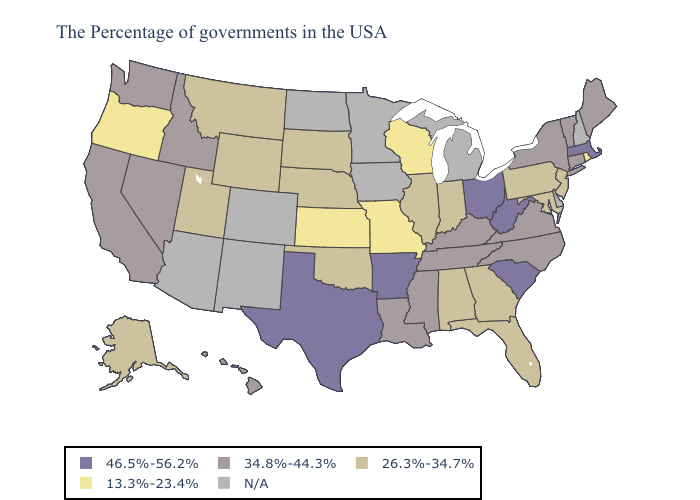What is the lowest value in the Northeast?
Short answer required. 13.3%-23.4%. Does Ohio have the highest value in the USA?
Write a very short answer. Yes. Does Texas have the highest value in the South?
Write a very short answer. Yes. Name the states that have a value in the range 46.5%-56.2%?
Answer briefly. Massachusetts, South Carolina, West Virginia, Ohio, Arkansas, Texas. Among the states that border Washington , does Idaho have the highest value?
Quick response, please. Yes. Name the states that have a value in the range 34.8%-44.3%?
Write a very short answer. Maine, Vermont, Connecticut, New York, Virginia, North Carolina, Kentucky, Tennessee, Mississippi, Louisiana, Idaho, Nevada, California, Washington, Hawaii. Which states hav the highest value in the Northeast?
Keep it brief. Massachusetts. Which states hav the highest value in the West?
Write a very short answer. Idaho, Nevada, California, Washington, Hawaii. What is the value of Kansas?
Short answer required. 13.3%-23.4%. What is the value of Delaware?
Give a very brief answer. N/A. Name the states that have a value in the range N/A?
Quick response, please. New Hampshire, Delaware, Michigan, Minnesota, Iowa, North Dakota, Colorado, New Mexico, Arizona. Which states have the highest value in the USA?
Answer briefly. Massachusetts, South Carolina, West Virginia, Ohio, Arkansas, Texas. Among the states that border Missouri , which have the highest value?
Answer briefly. Arkansas. 